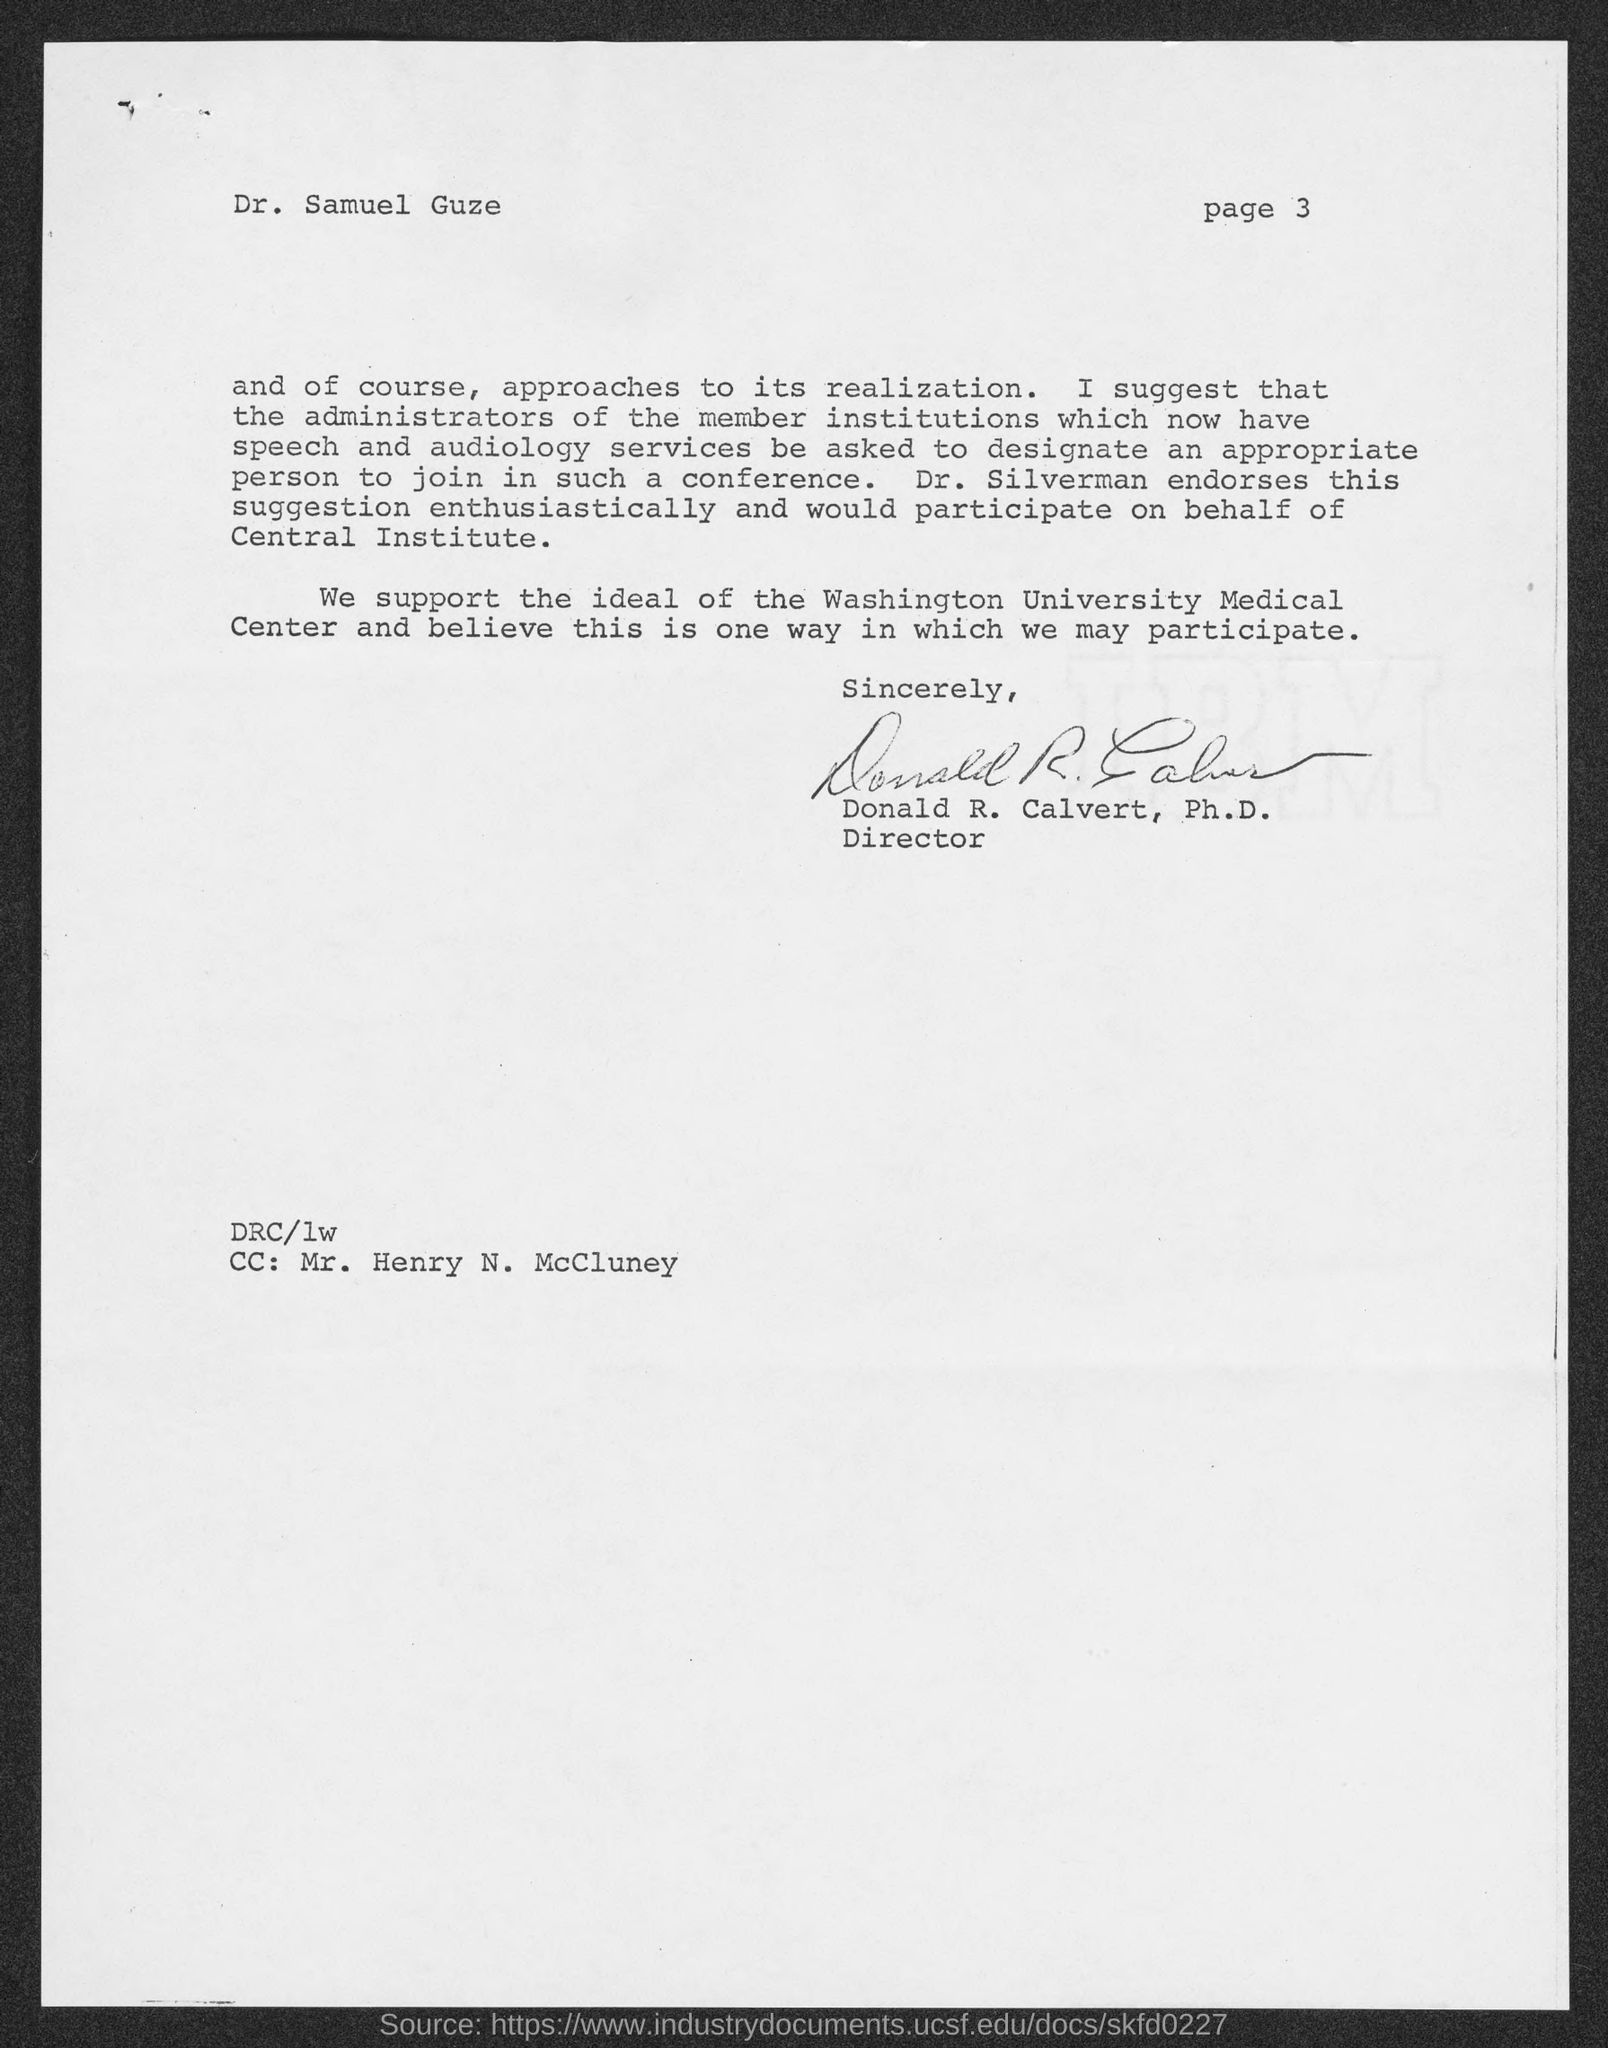What is the Page number ?
Offer a very short reply. Page 3. Who is the Director ?
Give a very brief answer. Donald R. Calvert, Ph.D. Who is memorandum address to ?
Give a very brief answer. Dr. Samuel Guze. Who is the "CC" Address ?
Provide a succinct answer. Mr. Henry N. McCluney. 